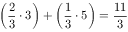<formula> <loc_0><loc_0><loc_500><loc_500>\left ( { \frac { 2 } { 3 } } \cdot 3 \right ) + \left ( { \frac { 1 } { 3 } } \cdot 5 \right ) = { \frac { 1 1 } { 3 } }</formula> 